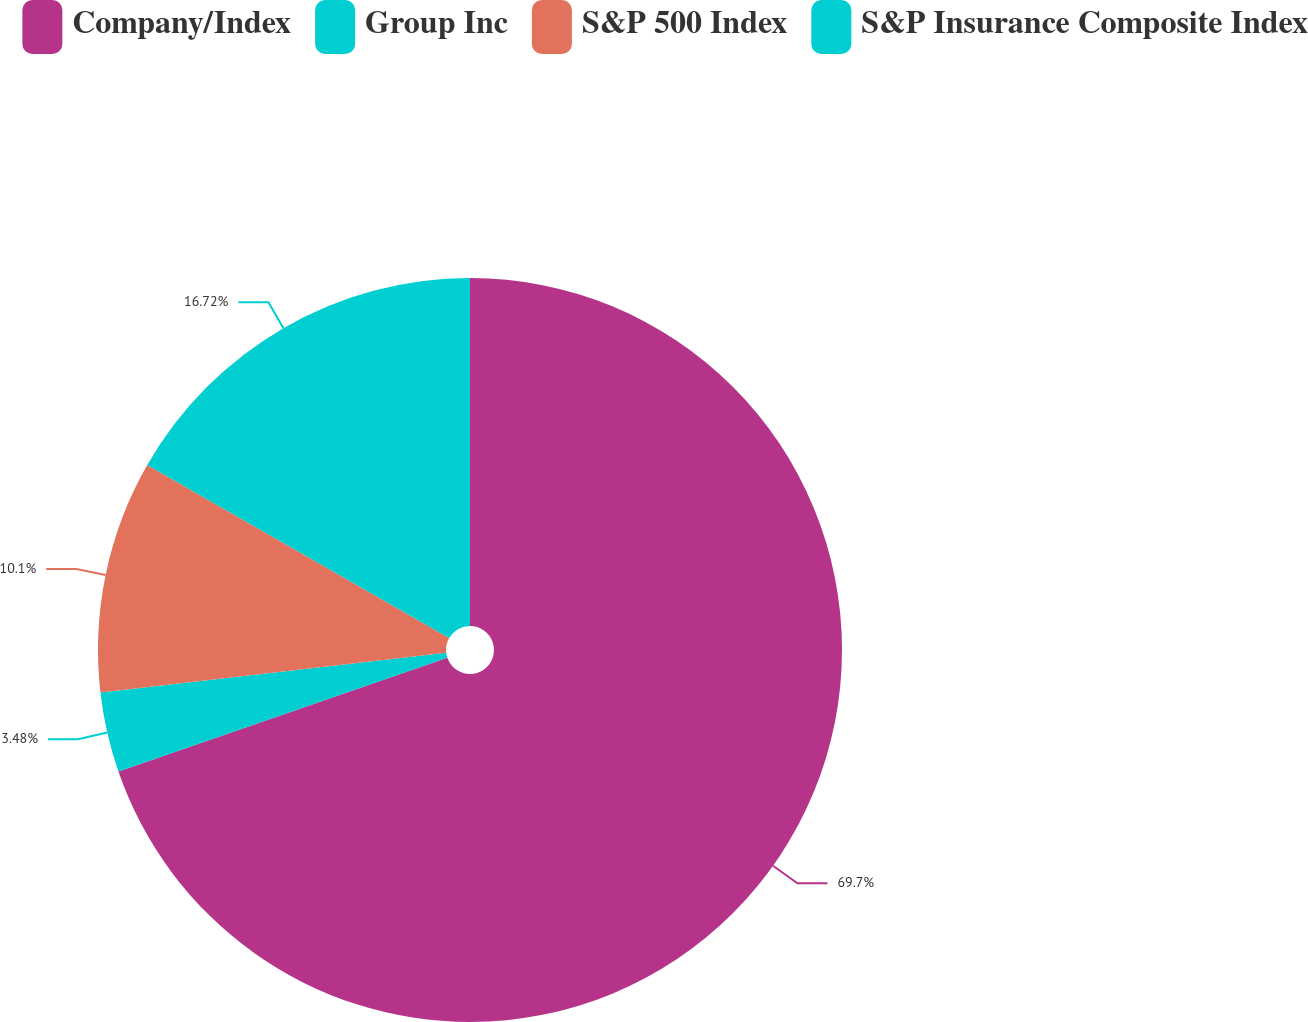<chart> <loc_0><loc_0><loc_500><loc_500><pie_chart><fcel>Company/Index<fcel>Group Inc<fcel>S&P 500 Index<fcel>S&P Insurance Composite Index<nl><fcel>69.7%<fcel>3.48%<fcel>10.1%<fcel>16.72%<nl></chart> 